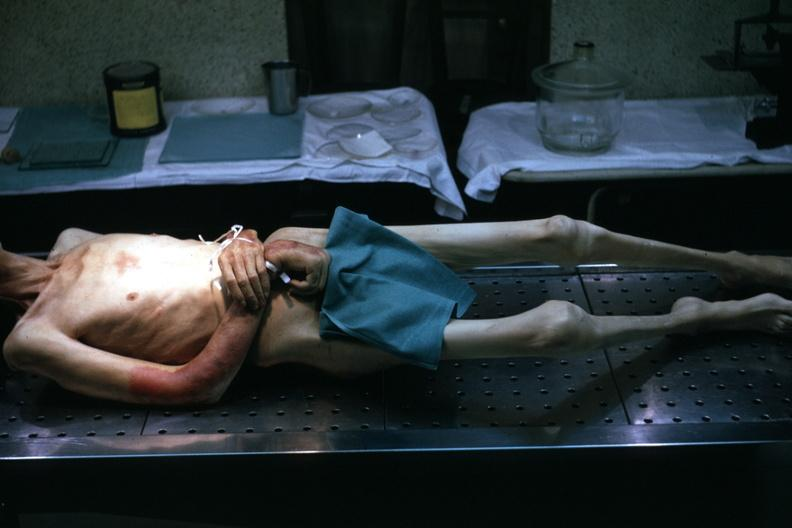s good example tastefully shown with face out of picture and genitalia covered muscle atrophy is striking?
Answer the question using a single word or phrase. Yes 